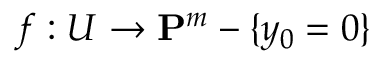Convert formula to latex. <formula><loc_0><loc_0><loc_500><loc_500>f \colon U \to P ^ { m } - \{ y _ { 0 } = 0 \}</formula> 